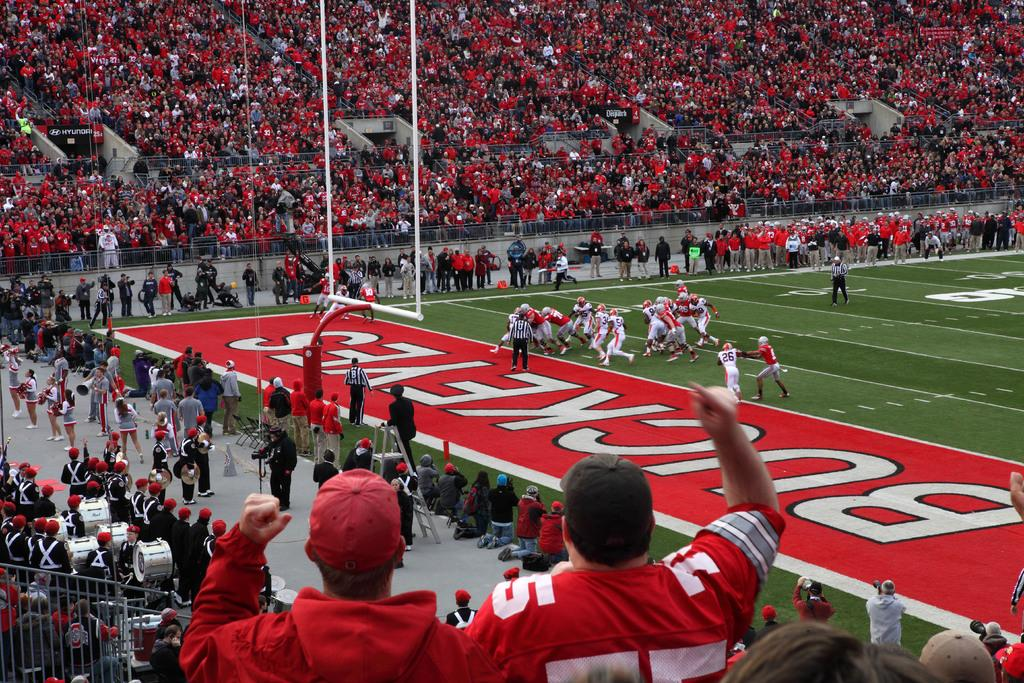<image>
Render a clear and concise summary of the photo. The stadium is for the football team the Ohio Buckeyes 